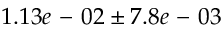Convert formula to latex. <formula><loc_0><loc_0><loc_500><loc_500>1 . 1 3 e - 0 2 \pm 7 . 8 e - 0 3</formula> 